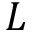<formula> <loc_0><loc_0><loc_500><loc_500>L</formula> 